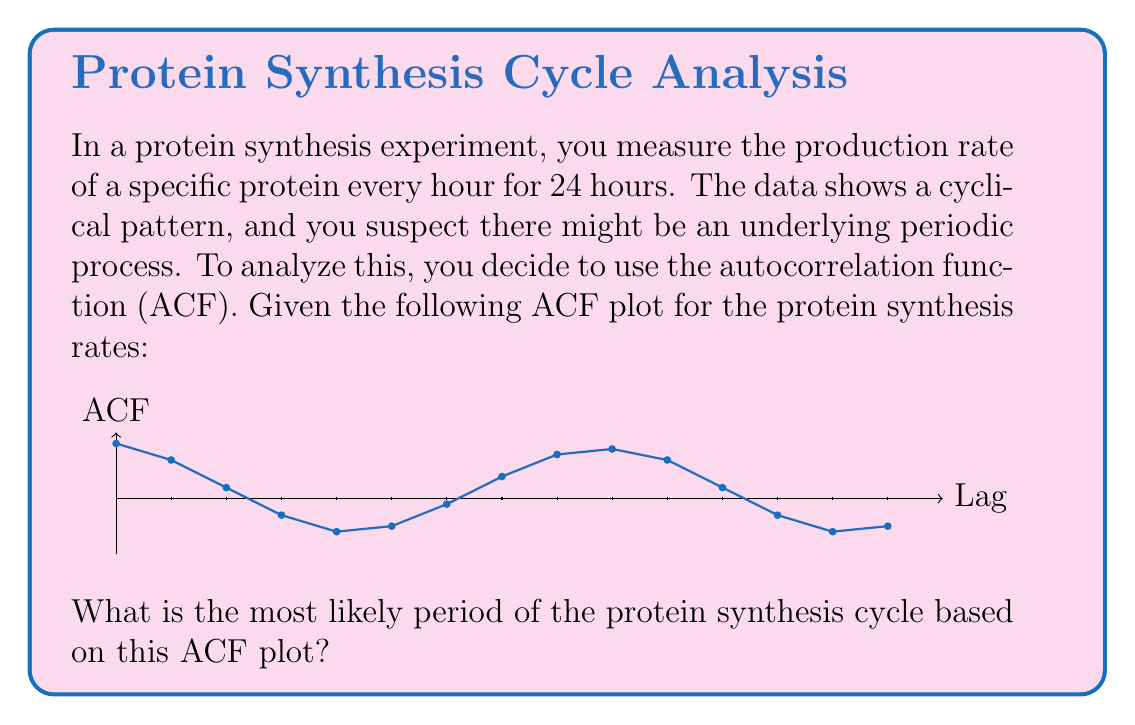Show me your answer to this math problem. To determine the period of the protein synthesis cycle from the autocorrelation function (ACF) plot, we need to follow these steps:

1. Understand the ACF plot:
   - The x-axis represents the lag (time difference) between observations.
   - The y-axis represents the correlation coefficient at each lag.
   - A peak in the ACF indicates a strong correlation at that lag.

2. Identify the pattern:
   - We see that the ACF starts at 1 (lag 0, perfect correlation with itself).
   - The ACF then decreases, becomes negative, and then increases again.
   - This pattern repeats, indicating a cyclical behavior.

3. Find the first strong positive peak after lag 0:
   - We observe a strong positive peak at lag 8.
   - This suggests that the data is most similar to itself after 8 time units.

4. Interpret the result:
   - Since each lag represents 1 hour in our experiment, a lag of 8 corresponds to 8 hours.
   - This means the protein synthesis rate pattern repeats approximately every 8 hours.

5. Verify the pattern:
   - We can see that the next strong positive peak occurs at lag 16 (8 * 2), further confirming our conclusion.

Therefore, based on the ACF plot, the most likely period of the protein synthesis cycle is 8 hours.
Answer: 8 hours 